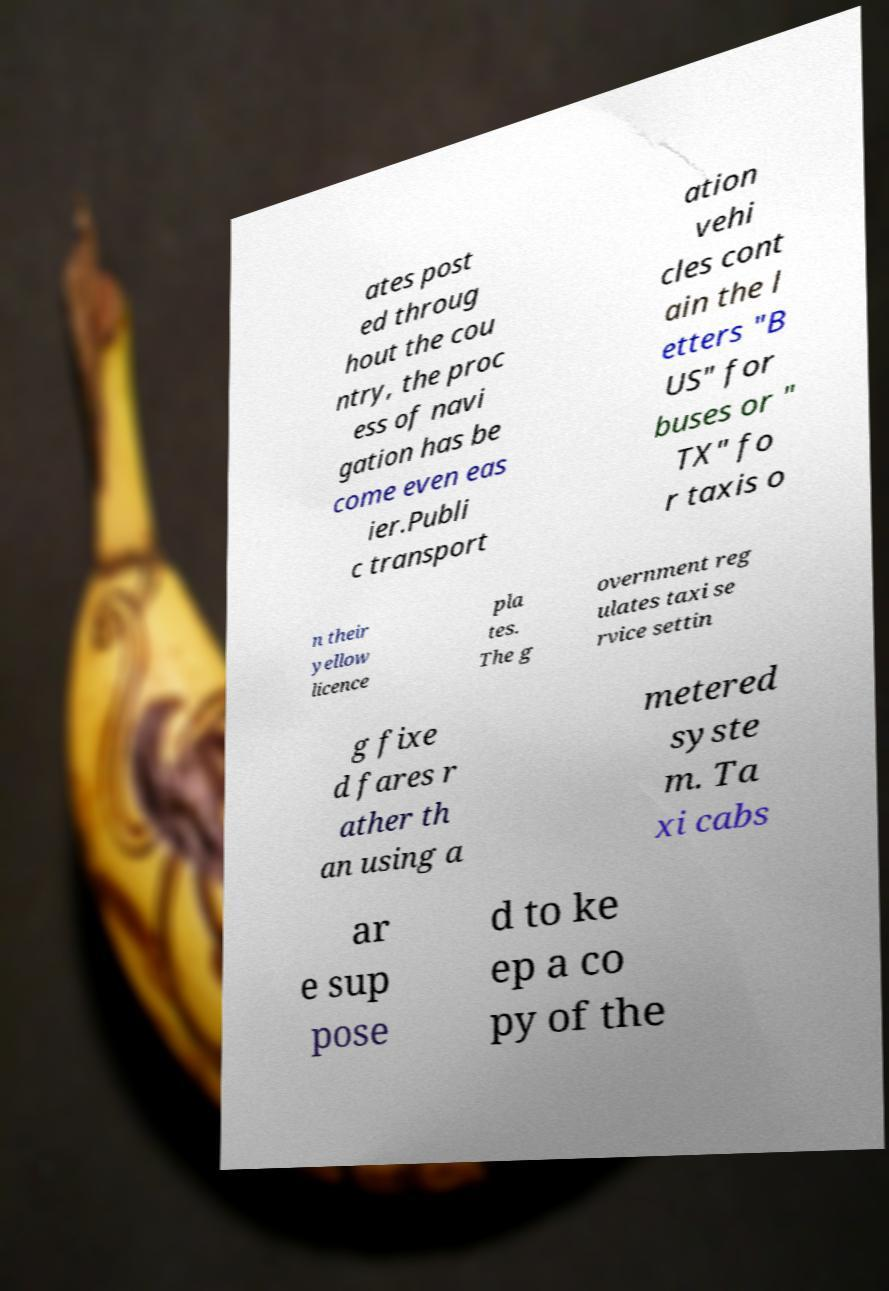Please read and relay the text visible in this image. What does it say? ates post ed throug hout the cou ntry, the proc ess of navi gation has be come even eas ier.Publi c transport ation vehi cles cont ain the l etters "B US" for buses or " TX" fo r taxis o n their yellow licence pla tes. The g overnment reg ulates taxi se rvice settin g fixe d fares r ather th an using a metered syste m. Ta xi cabs ar e sup pose d to ke ep a co py of the 